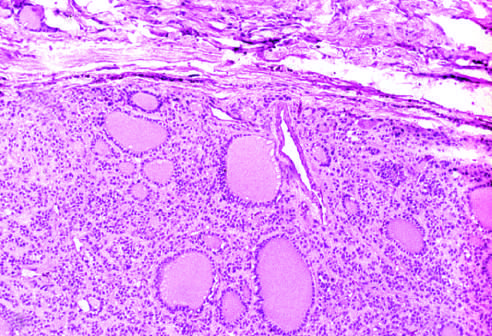re the necrotic cells seen?
Answer the question using a single word or phrase. No 